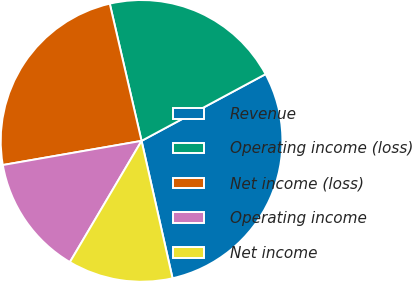Convert chart. <chart><loc_0><loc_0><loc_500><loc_500><pie_chart><fcel>Revenue<fcel>Operating income (loss)<fcel>Net income (loss)<fcel>Operating income<fcel>Net income<nl><fcel>29.33%<fcel>20.77%<fcel>24.12%<fcel>13.76%<fcel>12.03%<nl></chart> 